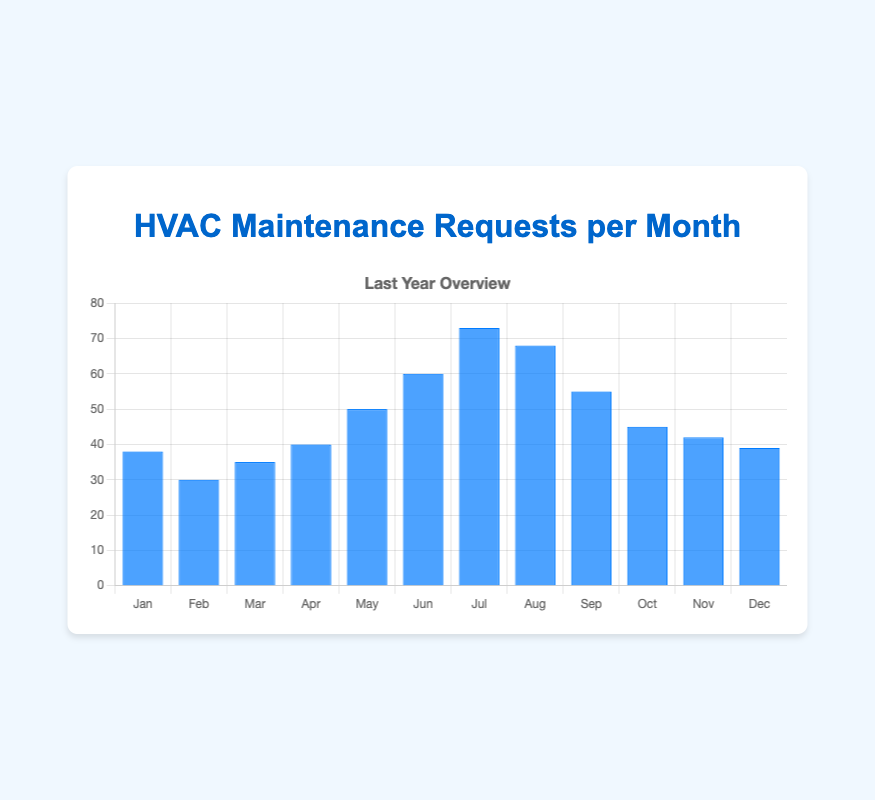Which month had the highest number of HVAC maintenance requests? The bar representing July is the tallest in the chart, indicating it had the highest number of requests.
Answer: July Which month had fewer HVAC maintenance requests, February or March? By comparing the heights of the bars for February and March, it is clear that the February bar is shorter than the March bar.
Answer: February What is the total number of HVAC maintenance requests in the summer months (June, July, and August)? Sum the values for June, July, and August: 60 + 73 + 68 = 201.
Answer: 201 How many more maintenance requests were there in July compared to January? Subtract the number of requests in January from the number in July: 73 - 38 = 35.
Answer: 35 Did April have more or fewer requests compared to the average monthly requests over the year? First, calculate the total number of requests for the year: 38 + 30 + 35 + 40 + 50 + 60 + 73 + 68 + 55 + 45 + 42 + 39 = 575. The average is 575 / 12 ≈ 47.92. April had 40 requests, which is fewer than the average.
Answer: Fewer Which month had the second-highest number of HVAC maintenance requests? The bar for August is the second-tallest after July, so August had the second-highest number of requests.
Answer: August Compare the HVAC maintenance requests in Q1 (January to March) and Q4 (October to December). Which quarter had more requests? Sum the requests in Q1: 38 + 30 + 35 = 103. Sum the requests in Q4: 45 + 42 + 39 = 126. Q4 had more requests.
Answer: Q4 Is there a noticeable trend in the number of HVAC maintenance requests as the year progresses? Observing the chart, the number of requests increases from January to July, peaks in July, and then decreases towards December.
Answer: Yes, increasing then decreasing How much higher was the number of requests in May compared to February? Subtract the number of requests in February from May: 50 - 30 = 20.
Answer: 20 